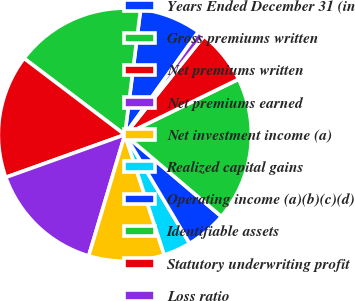<chart> <loc_0><loc_0><loc_500><loc_500><pie_chart><fcel>Years Ended December 31 (in<fcel>Gross premiums written<fcel>Net premiums written<fcel>Net premiums earned<fcel>Net investment income (a)<fcel>Realized capital gains<fcel>Operating income (a)(b)(c)(d)<fcel>Identifiable assets<fcel>Statutory underwriting profit<fcel>Loss ratio<nl><fcel>7.89%<fcel>16.67%<fcel>15.79%<fcel>14.91%<fcel>9.65%<fcel>3.51%<fcel>5.26%<fcel>18.42%<fcel>7.02%<fcel>0.88%<nl></chart> 